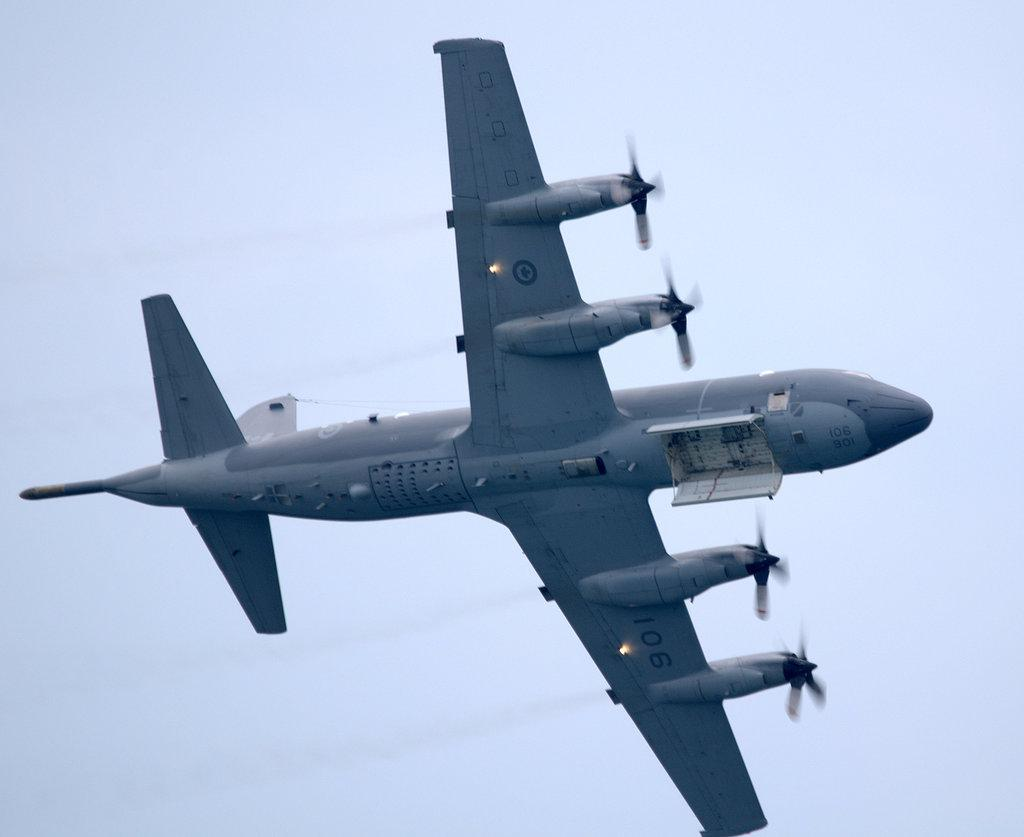What is the main subject of the picture? The main subject of the picture is a jet plane. What is the color of the sky in the picture? The sky is blue in the picture. Where is the library located in the image? There is no library present in the image; it features a jet plane and a blue sky. What type of kite is being flown by the person in the image? There is no person or kite present in the image. 